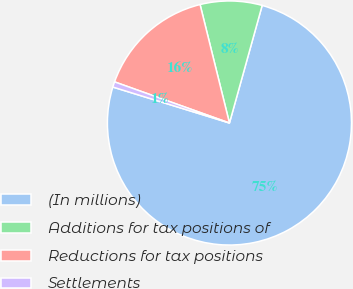Convert chart to OTSL. <chart><loc_0><loc_0><loc_500><loc_500><pie_chart><fcel>(In millions)<fcel>Additions for tax positions of<fcel>Reductions for tax positions<fcel>Settlements<nl><fcel>75.44%<fcel>8.19%<fcel>15.66%<fcel>0.71%<nl></chart> 